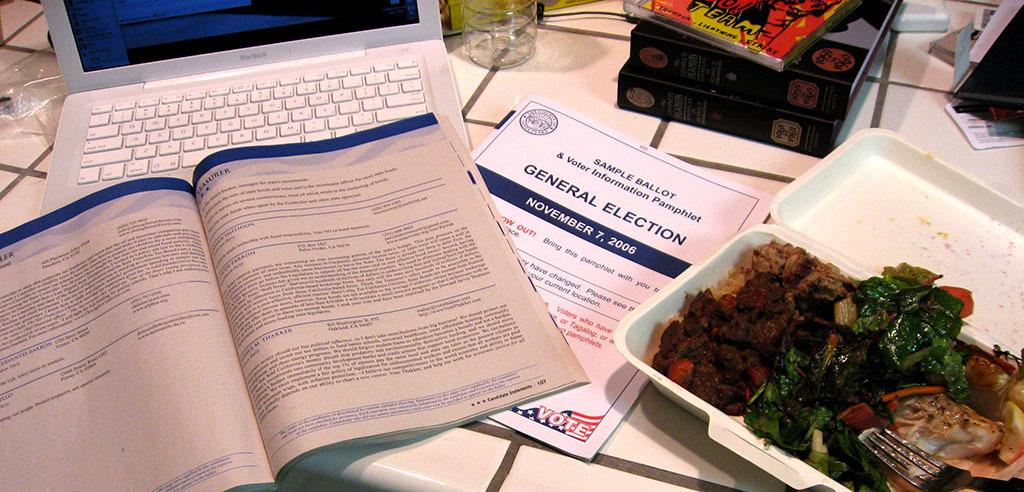<image>
Give a short and clear explanation of the subsequent image. A sample ballot for the general election sits on a table near a laptop and some takeout food. 